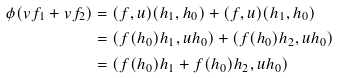Convert formula to latex. <formula><loc_0><loc_0><loc_500><loc_500>\phi ( v f _ { 1 } + v f _ { 2 } ) & = ( f , u ) ( h _ { 1 } , h _ { 0 } ) + ( f , u ) ( h _ { 1 } , h _ { 0 } ) \\ & = ( f ( h _ { 0 } ) h _ { 1 } , u h _ { 0 } ) + ( f ( h _ { 0 } ) h _ { 2 } , u h _ { 0 } ) \\ & = ( f ( h _ { 0 } ) h _ { 1 } + f ( h _ { 0 } ) h _ { 2 } , u h _ { 0 } )</formula> 